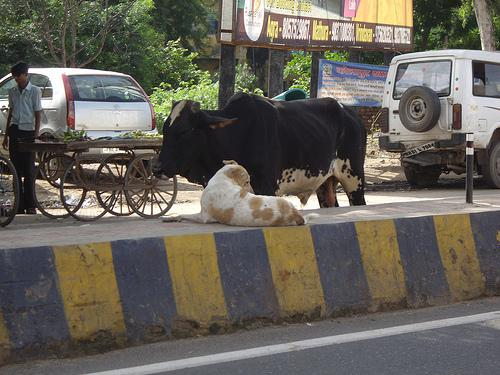Question: how many vehicles arein the photo?
Choices:
A. Three.
B. Four.
C. Five.
D. Two.
Answer with the letter. Answer: D Question: what is in front of the cow?
Choices:
A. Dog.
B. Meadow.
C. Grass.
D. Farm.
Answer with the letter. Answer: A Question: what color is the cow?
Choices:
A. White.
B. Brown.
C. Black.
D. Black and white.
Answer with the letter. Answer: C Question: how many wheels does the cart have?
Choices:
A. None.
B. One.
C. Two.
D. Four.
Answer with the letter. Answer: D 